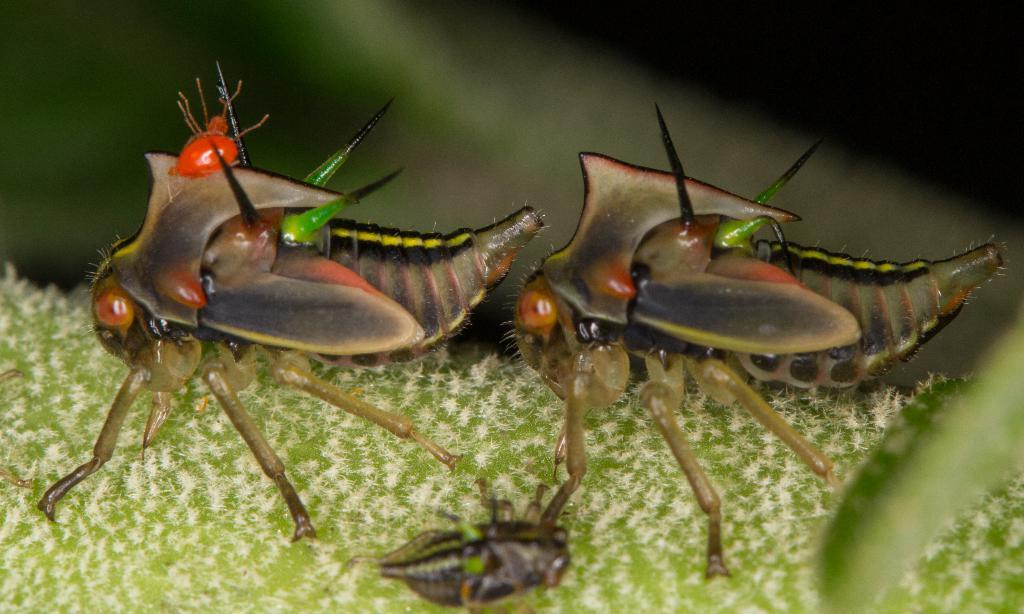What type of creatures can be seen in the image? There are insects in the image. What is the color of the surface where the insects are located? The insects are on a green surface. Can you describe the background of the image? The background of the image is blurred. What type of underwear is visible in the image? There is no underwear present in the image. What type of system is being used to process the insects in the image? There is no system present in the image, and the insects are not being processed. 